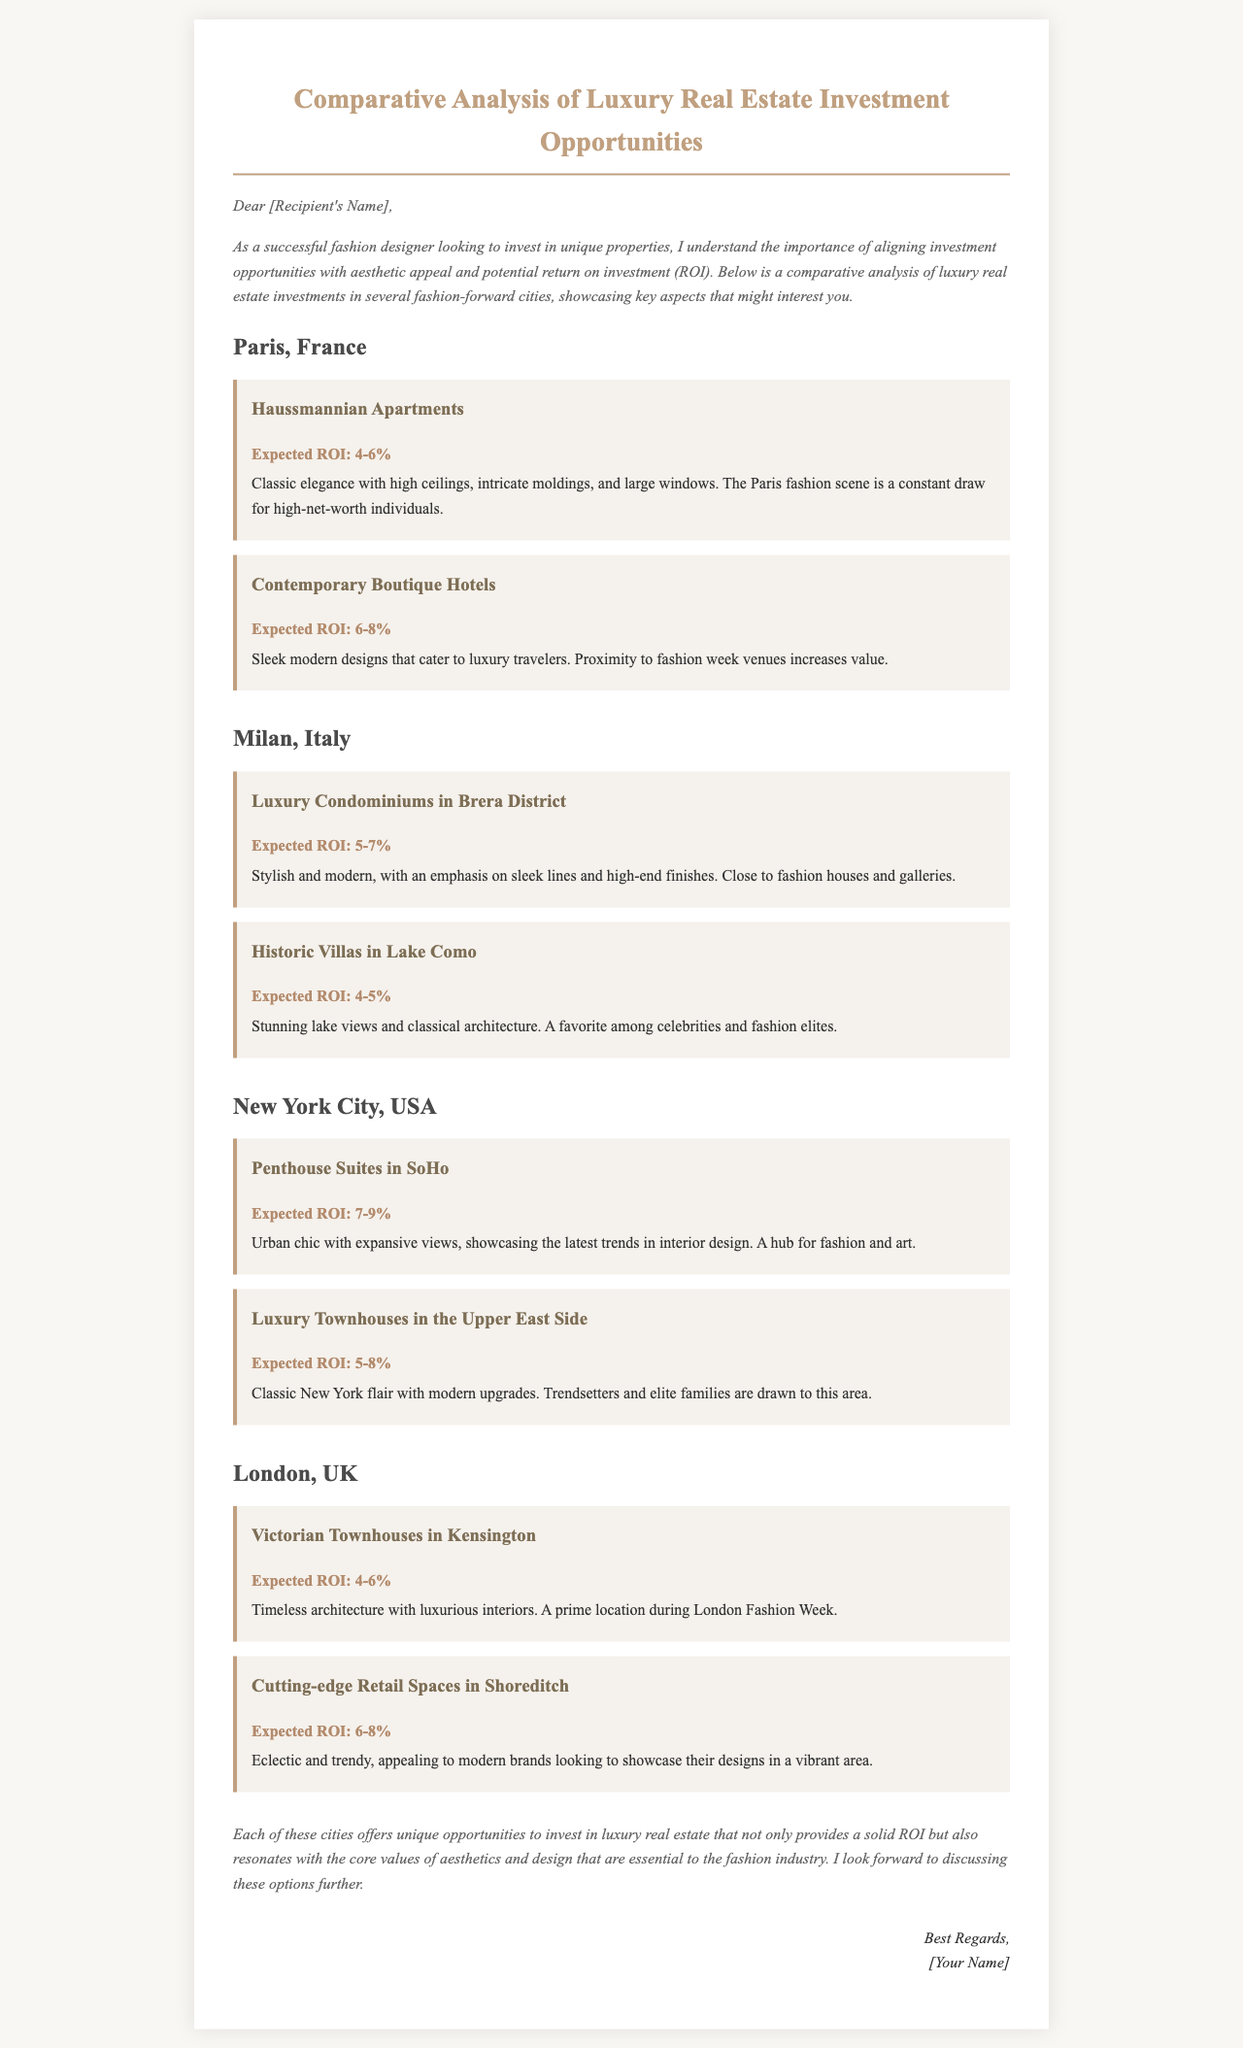What is the expected ROI for Haussmannian Apartments in Paris? The document specifies that the expected ROI for Haussmannian Apartments in Paris is between 4-6%.
Answer: 4-6% What city offers Luxury Townhouses in the Upper East Side? The document lists New York City as the location for Luxury Townhouses in the Upper East Side.
Answer: New York City Which property type has the highest expected ROI in New York City? The document indicates that Penthouse Suites in SoHo have the highest expected ROI of 7-9% in New York City.
Answer: Penthouse Suites in SoHo What design aesthetic do Contemporary Boutique Hotels in Paris cater to? The document states that Contemporary Boutique Hotels have sleek modern designs catering to luxury travelers.
Answer: Sleek modern designs Which city features Historic Villas in Lake Como? The document mentions that Historic Villas can be found in Milan, Italy.
Answer: Milan, Italy What is a key feature of Victorian Townhouses in Kensington? The document describes Victorian Townhouses as having timeless architecture with luxurious interiors.
Answer: Timeless architecture What is the expected ROI range for Cutting-edge Retail Spaces in Shoreditch? The document states that the expected ROI for Cutting-edge Retail Spaces in Shoreditch is between 6-8%.
Answer: 6-8% Which property type is associated with high-net-worth individuals in Paris? The document associates Haussmannian Apartments with high-net-worth individuals in Paris.
Answer: Haussmannian Apartments What type of properties are located in Brera District, Milan? The document specifies that Luxury Condominiums are located in the Brera District.
Answer: Luxury Condominiums 